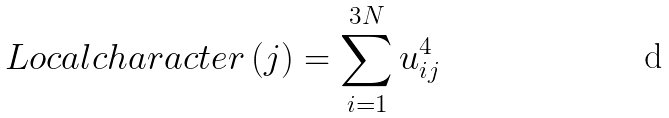Convert formula to latex. <formula><loc_0><loc_0><loc_500><loc_500>L o c a l c h a r a c t e r \left ( j \right ) = \sum _ { i = 1 } ^ { 3 N } u _ { i j } ^ { 4 }</formula> 